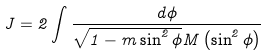Convert formula to latex. <formula><loc_0><loc_0><loc_500><loc_500>J = 2 \int \frac { d \phi } { \sqrt { 1 - m \sin ^ { 2 } \phi } M \left ( \sin ^ { 2 } \phi \right ) }</formula> 